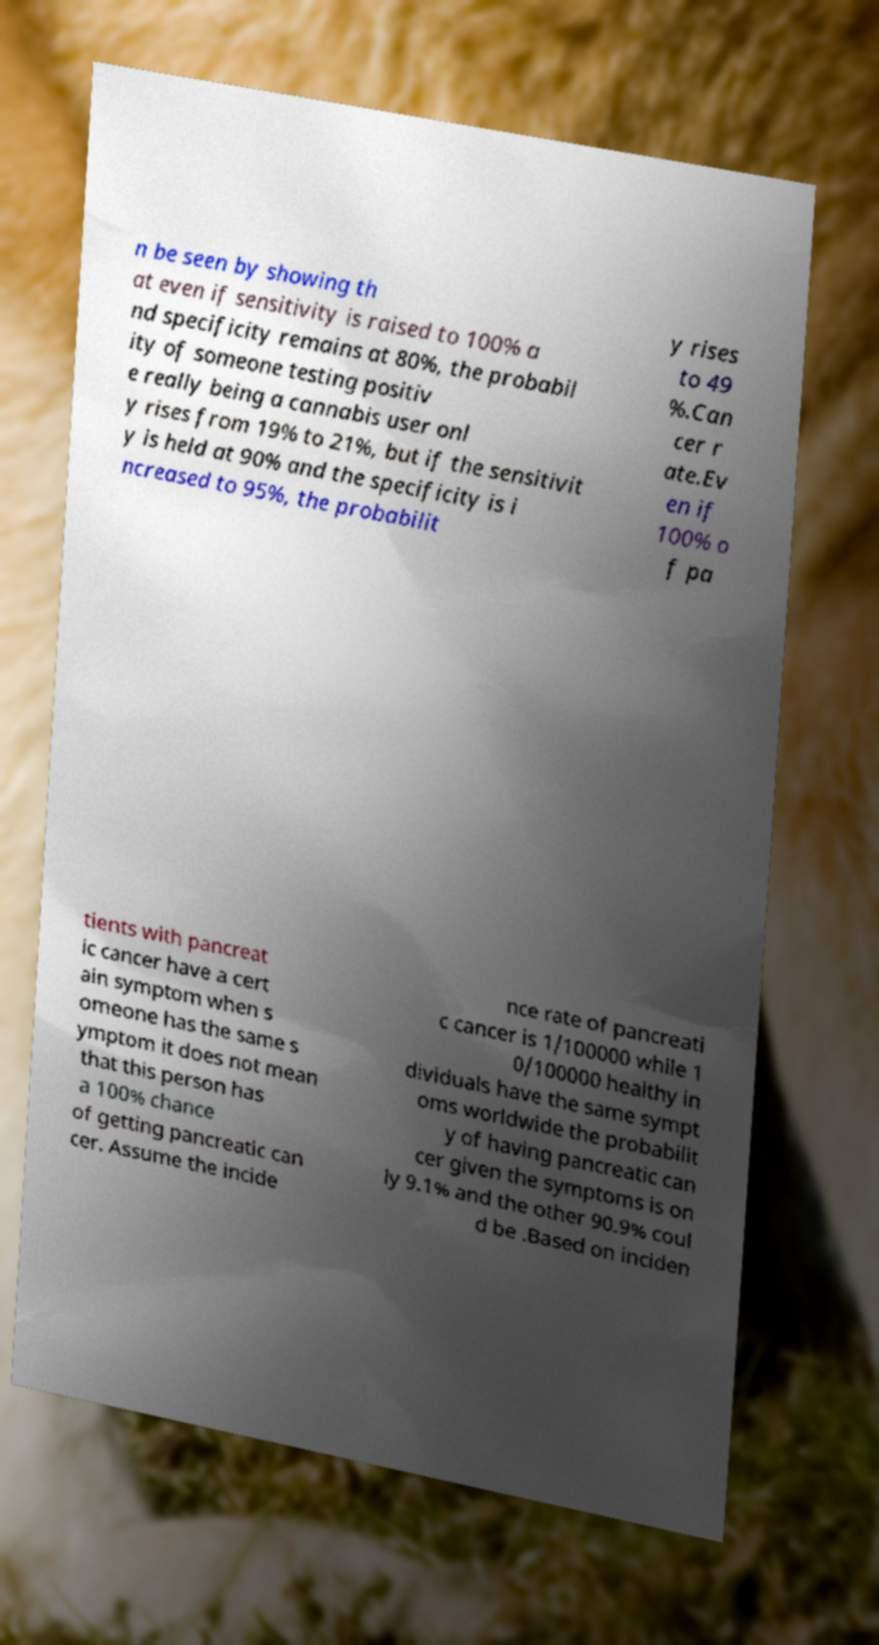For documentation purposes, I need the text within this image transcribed. Could you provide that? n be seen by showing th at even if sensitivity is raised to 100% a nd specificity remains at 80%, the probabil ity of someone testing positiv e really being a cannabis user onl y rises from 19% to 21%, but if the sensitivit y is held at 90% and the specificity is i ncreased to 95%, the probabilit y rises to 49 %.Can cer r ate.Ev en if 100% o f pa tients with pancreat ic cancer have a cert ain symptom when s omeone has the same s ymptom it does not mean that this person has a 100% chance of getting pancreatic can cer. Assume the incide nce rate of pancreati c cancer is 1/100000 while 1 0/100000 healthy in dividuals have the same sympt oms worldwide the probabilit y of having pancreatic can cer given the symptoms is on ly 9.1% and the other 90.9% coul d be .Based on inciden 